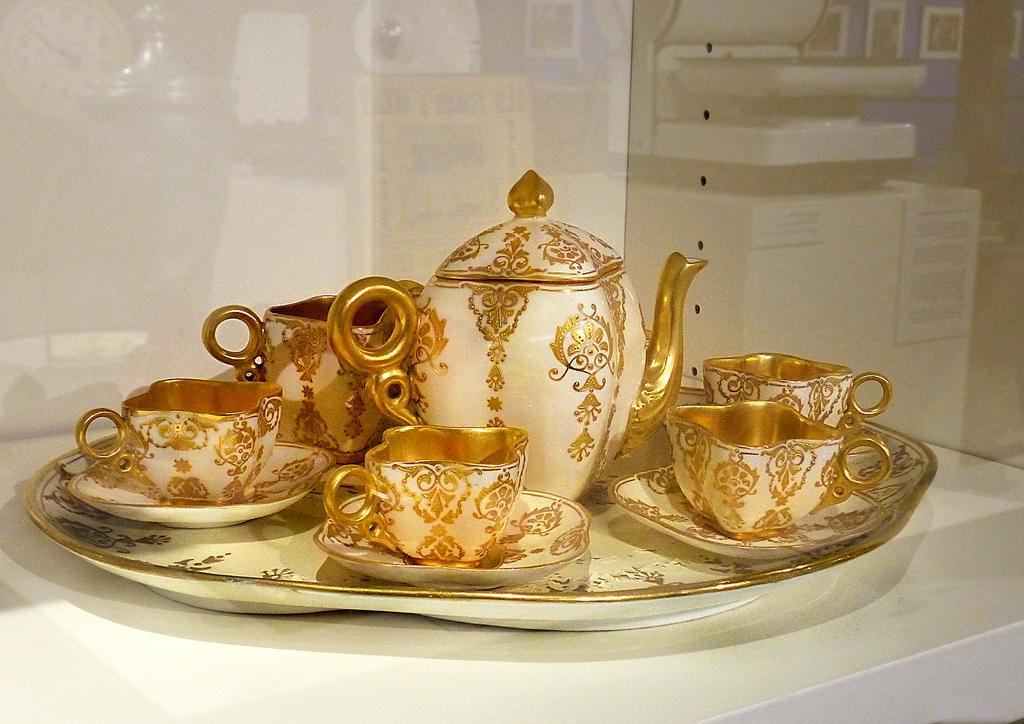How would you summarize this image in a sentence or two? There is a white surface. On that there is a tray. On the train there are cups, saucers and a kettle. 